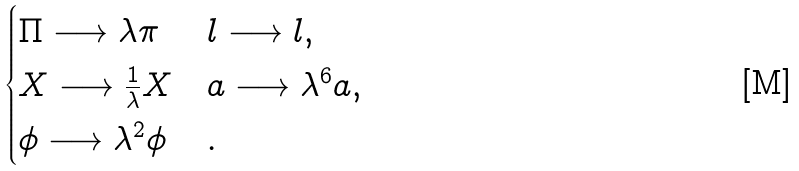Convert formula to latex. <formula><loc_0><loc_0><loc_500><loc_500>\begin{cases} \Pi \longrightarrow \lambda \pi & l \longrightarrow { l } , \\ X \longrightarrow \frac { 1 } { \lambda } X & a \longrightarrow \lambda ^ { 6 } a , \\ \phi \longrightarrow \lambda ^ { 2 } \phi & . \end{cases}</formula> 